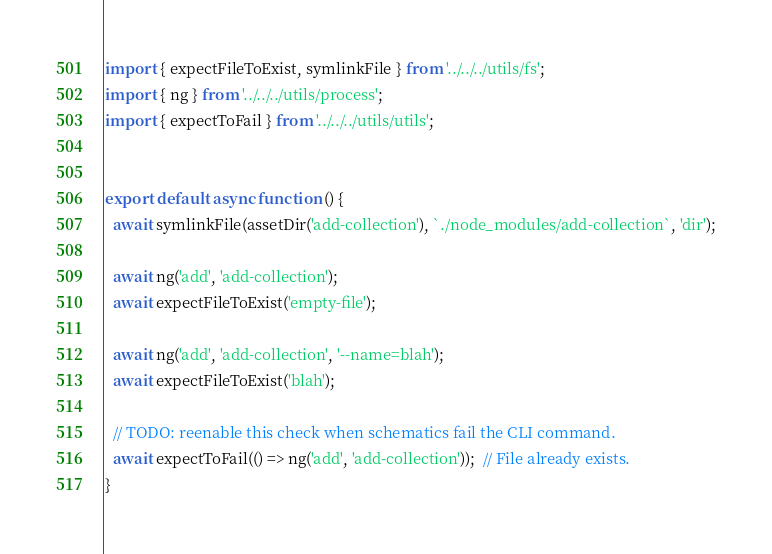<code> <loc_0><loc_0><loc_500><loc_500><_TypeScript_>import { expectFileToExist, symlinkFile } from '../../../utils/fs';
import { ng } from '../../../utils/process';
import { expectToFail } from '../../../utils/utils';


export default async function () {
  await symlinkFile(assetDir('add-collection'), `./node_modules/add-collection`, 'dir');

  await ng('add', 'add-collection');
  await expectFileToExist('empty-file');

  await ng('add', 'add-collection', '--name=blah');
  await expectFileToExist('blah');

  // TODO: reenable this check when schematics fail the CLI command.
  await expectToFail(() => ng('add', 'add-collection'));  // File already exists.
}
</code> 